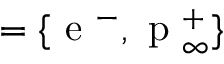Convert formula to latex. <formula><loc_0><loc_0><loc_500><loc_500>= \{ e ^ { - } , p _ { \infty } ^ { + } \}</formula> 